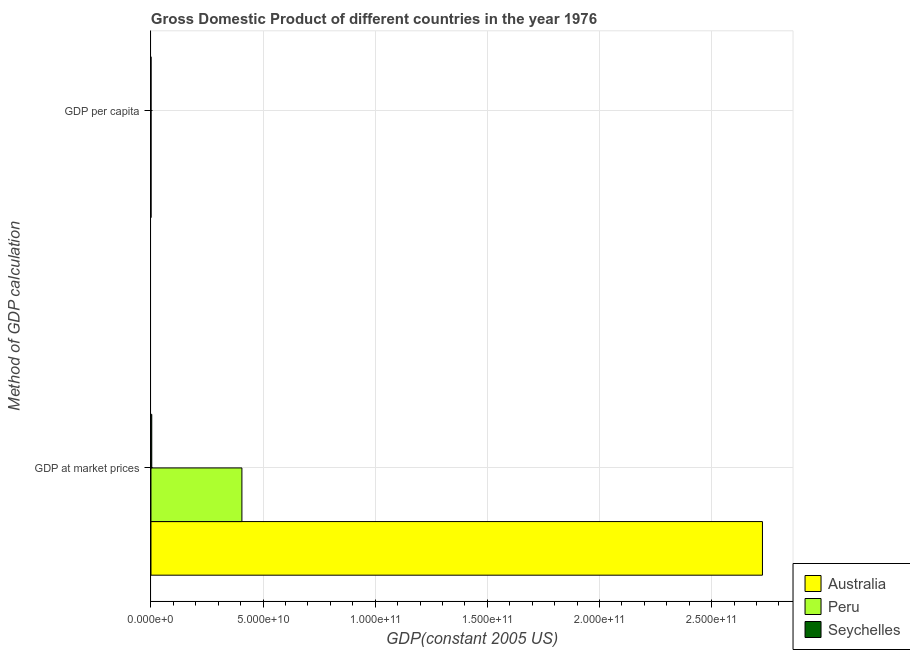How many groups of bars are there?
Ensure brevity in your answer.  2. How many bars are there on the 1st tick from the bottom?
Ensure brevity in your answer.  3. What is the label of the 2nd group of bars from the top?
Offer a very short reply. GDP at market prices. What is the gdp at market prices in Australia?
Your response must be concise. 2.73e+11. Across all countries, what is the maximum gdp at market prices?
Ensure brevity in your answer.  2.73e+11. Across all countries, what is the minimum gdp per capita?
Give a very brief answer. 2593.09. In which country was the gdp per capita minimum?
Keep it short and to the point. Peru. What is the total gdp at market prices in the graph?
Offer a terse response. 3.14e+11. What is the difference between the gdp per capita in Peru and that in Seychelles?
Provide a short and direct response. -3348.24. What is the difference between the gdp per capita in Seychelles and the gdp at market prices in Peru?
Make the answer very short. -4.06e+1. What is the average gdp at market prices per country?
Offer a very short reply. 1.05e+11. What is the difference between the gdp per capita and gdp at market prices in Australia?
Make the answer very short. -2.73e+11. In how many countries, is the gdp at market prices greater than 110000000000 US$?
Your answer should be compact. 1. What is the ratio of the gdp at market prices in Australia to that in Peru?
Your answer should be compact. 6.72. In how many countries, is the gdp per capita greater than the average gdp per capita taken over all countries?
Give a very brief answer. 1. How many bars are there?
Provide a short and direct response. 6. Are all the bars in the graph horizontal?
Make the answer very short. Yes. How many countries are there in the graph?
Provide a short and direct response. 3. What is the difference between two consecutive major ticks on the X-axis?
Make the answer very short. 5.00e+1. Are the values on the major ticks of X-axis written in scientific E-notation?
Provide a short and direct response. Yes. Does the graph contain any zero values?
Keep it short and to the point. No. Does the graph contain grids?
Offer a very short reply. Yes. How many legend labels are there?
Ensure brevity in your answer.  3. What is the title of the graph?
Offer a very short reply. Gross Domestic Product of different countries in the year 1976. Does "Nicaragua" appear as one of the legend labels in the graph?
Provide a succinct answer. No. What is the label or title of the X-axis?
Offer a very short reply. GDP(constant 2005 US). What is the label or title of the Y-axis?
Your response must be concise. Method of GDP calculation. What is the GDP(constant 2005 US) of Australia in GDP at market prices?
Give a very brief answer. 2.73e+11. What is the GDP(constant 2005 US) in Peru in GDP at market prices?
Provide a short and direct response. 4.06e+1. What is the GDP(constant 2005 US) in Seychelles in GDP at market prices?
Keep it short and to the point. 3.61e+08. What is the GDP(constant 2005 US) of Australia in GDP per capita?
Your response must be concise. 1.94e+04. What is the GDP(constant 2005 US) in Peru in GDP per capita?
Give a very brief answer. 2593.09. What is the GDP(constant 2005 US) in Seychelles in GDP per capita?
Make the answer very short. 5941.32. Across all Method of GDP calculation, what is the maximum GDP(constant 2005 US) in Australia?
Offer a very short reply. 2.73e+11. Across all Method of GDP calculation, what is the maximum GDP(constant 2005 US) in Peru?
Keep it short and to the point. 4.06e+1. Across all Method of GDP calculation, what is the maximum GDP(constant 2005 US) of Seychelles?
Offer a very short reply. 3.61e+08. Across all Method of GDP calculation, what is the minimum GDP(constant 2005 US) in Australia?
Your answer should be very brief. 1.94e+04. Across all Method of GDP calculation, what is the minimum GDP(constant 2005 US) of Peru?
Offer a terse response. 2593.09. Across all Method of GDP calculation, what is the minimum GDP(constant 2005 US) of Seychelles?
Your response must be concise. 5941.32. What is the total GDP(constant 2005 US) in Australia in the graph?
Offer a terse response. 2.73e+11. What is the total GDP(constant 2005 US) of Peru in the graph?
Your answer should be very brief. 4.06e+1. What is the total GDP(constant 2005 US) in Seychelles in the graph?
Your response must be concise. 3.61e+08. What is the difference between the GDP(constant 2005 US) of Australia in GDP at market prices and that in GDP per capita?
Give a very brief answer. 2.73e+11. What is the difference between the GDP(constant 2005 US) in Peru in GDP at market prices and that in GDP per capita?
Give a very brief answer. 4.06e+1. What is the difference between the GDP(constant 2005 US) of Seychelles in GDP at market prices and that in GDP per capita?
Your response must be concise. 3.61e+08. What is the difference between the GDP(constant 2005 US) in Australia in GDP at market prices and the GDP(constant 2005 US) in Peru in GDP per capita?
Provide a succinct answer. 2.73e+11. What is the difference between the GDP(constant 2005 US) of Australia in GDP at market prices and the GDP(constant 2005 US) of Seychelles in GDP per capita?
Provide a succinct answer. 2.73e+11. What is the difference between the GDP(constant 2005 US) in Peru in GDP at market prices and the GDP(constant 2005 US) in Seychelles in GDP per capita?
Your answer should be compact. 4.06e+1. What is the average GDP(constant 2005 US) of Australia per Method of GDP calculation?
Your answer should be very brief. 1.36e+11. What is the average GDP(constant 2005 US) of Peru per Method of GDP calculation?
Make the answer very short. 2.03e+1. What is the average GDP(constant 2005 US) of Seychelles per Method of GDP calculation?
Your answer should be very brief. 1.80e+08. What is the difference between the GDP(constant 2005 US) of Australia and GDP(constant 2005 US) of Peru in GDP at market prices?
Offer a terse response. 2.32e+11. What is the difference between the GDP(constant 2005 US) in Australia and GDP(constant 2005 US) in Seychelles in GDP at market prices?
Offer a terse response. 2.72e+11. What is the difference between the GDP(constant 2005 US) of Peru and GDP(constant 2005 US) of Seychelles in GDP at market prices?
Provide a short and direct response. 4.02e+1. What is the difference between the GDP(constant 2005 US) of Australia and GDP(constant 2005 US) of Peru in GDP per capita?
Ensure brevity in your answer.  1.68e+04. What is the difference between the GDP(constant 2005 US) in Australia and GDP(constant 2005 US) in Seychelles in GDP per capita?
Offer a terse response. 1.35e+04. What is the difference between the GDP(constant 2005 US) of Peru and GDP(constant 2005 US) of Seychelles in GDP per capita?
Make the answer very short. -3348.24. What is the ratio of the GDP(constant 2005 US) in Australia in GDP at market prices to that in GDP per capita?
Your response must be concise. 1.40e+07. What is the ratio of the GDP(constant 2005 US) of Peru in GDP at market prices to that in GDP per capita?
Your response must be concise. 1.56e+07. What is the ratio of the GDP(constant 2005 US) of Seychelles in GDP at market prices to that in GDP per capita?
Give a very brief answer. 6.07e+04. What is the difference between the highest and the second highest GDP(constant 2005 US) of Australia?
Your answer should be very brief. 2.73e+11. What is the difference between the highest and the second highest GDP(constant 2005 US) of Peru?
Provide a short and direct response. 4.06e+1. What is the difference between the highest and the second highest GDP(constant 2005 US) of Seychelles?
Ensure brevity in your answer.  3.61e+08. What is the difference between the highest and the lowest GDP(constant 2005 US) in Australia?
Your response must be concise. 2.73e+11. What is the difference between the highest and the lowest GDP(constant 2005 US) in Peru?
Give a very brief answer. 4.06e+1. What is the difference between the highest and the lowest GDP(constant 2005 US) in Seychelles?
Keep it short and to the point. 3.61e+08. 